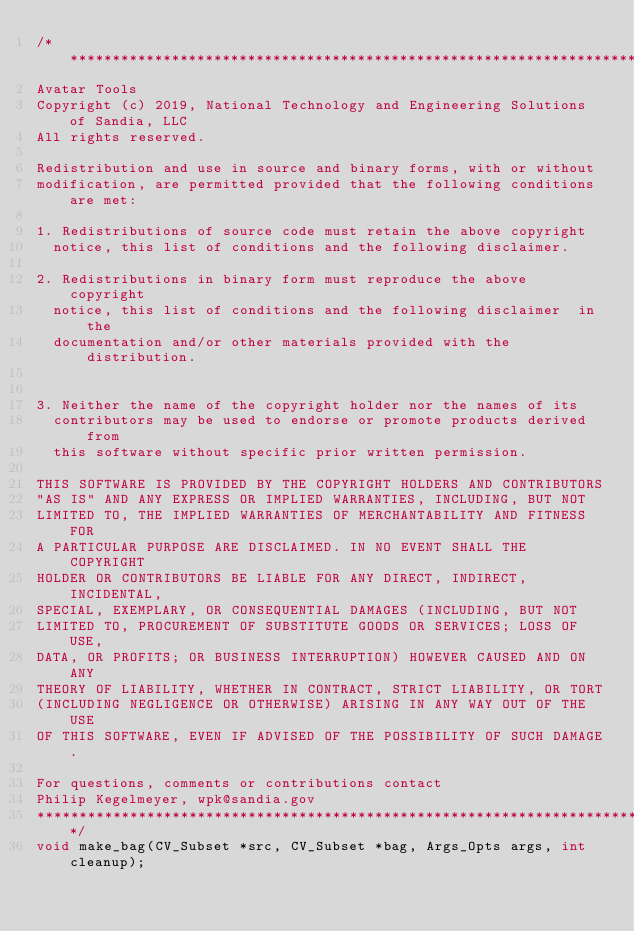Convert code to text. <code><loc_0><loc_0><loc_500><loc_500><_C_>/********************************************************************************** 
Avatar Tools 
Copyright (c) 2019, National Technology and Engineering Solutions of Sandia, LLC
All rights reserved. 

Redistribution and use in source and binary forms, with or without
modification, are permitted provided that the following conditions are met:

1. Redistributions of source code must retain the above copyright
  notice, this list of conditions and the following disclaimer.

2. Redistributions in binary form must reproduce the above copyright
  notice, this list of conditions and the following disclaimer  in the
  documentation and/or other materials provided with the distribution.


3. Neither the name of the copyright holder nor the names of its
  contributors may be used to endorse or promote products derived from
  this software without specific prior written permission.

THIS SOFTWARE IS PROVIDED BY THE COPYRIGHT HOLDERS AND CONTRIBUTORS
"AS IS" AND ANY EXPRESS OR IMPLIED WARRANTIES, INCLUDING, BUT NOT
LIMITED TO, THE IMPLIED WARRANTIES OF MERCHANTABILITY AND FITNESS FOR
A PARTICULAR PURPOSE ARE DISCLAIMED. IN NO EVENT SHALL THE COPYRIGHT
HOLDER OR CONTRIBUTORS BE LIABLE FOR ANY DIRECT, INDIRECT, INCIDENTAL,
SPECIAL, EXEMPLARY, OR CONSEQUENTIAL DAMAGES (INCLUDING, BUT NOT
LIMITED TO, PROCUREMENT OF SUBSTITUTE GOODS OR SERVICES; LOSS OF USE,
DATA, OR PROFITS; OR BUSINESS INTERRUPTION) HOWEVER CAUSED AND ON ANY
THEORY OF LIABILITY, WHETHER IN CONTRACT, STRICT LIABILITY, OR TORT
(INCLUDING NEGLIGENCE OR OTHERWISE) ARISING IN ANY WAY OUT OF THE USE
OF THIS SOFTWARE, EVEN IF ADVISED OF THE POSSIBILITY OF SUCH DAMAGE.

For questions, comments or contributions contact 
Philip Kegelmeyer, wpk@sandia.gov 
*******************************************************************************/
void make_bag(CV_Subset *src, CV_Subset *bag, Args_Opts args, int cleanup);
</code> 